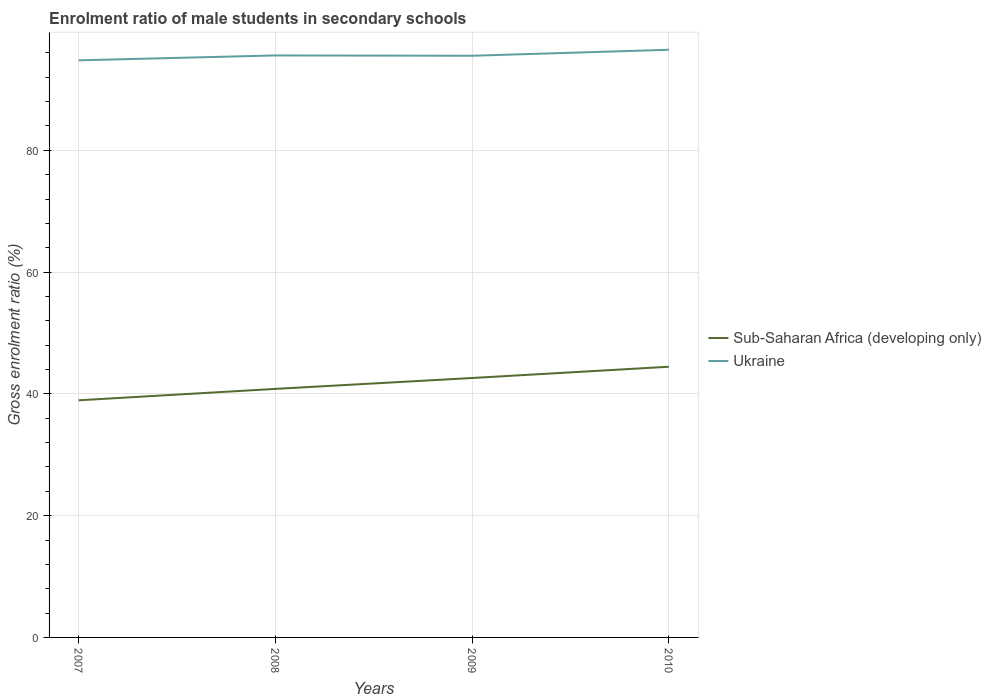Is the number of lines equal to the number of legend labels?
Make the answer very short. Yes. Across all years, what is the maximum enrolment ratio of male students in secondary schools in Sub-Saharan Africa (developing only)?
Your response must be concise. 38.94. In which year was the enrolment ratio of male students in secondary schools in Sub-Saharan Africa (developing only) maximum?
Ensure brevity in your answer.  2007. What is the total enrolment ratio of male students in secondary schools in Sub-Saharan Africa (developing only) in the graph?
Provide a short and direct response. -5.51. What is the difference between the highest and the second highest enrolment ratio of male students in secondary schools in Ukraine?
Offer a terse response. 1.73. What is the difference between the highest and the lowest enrolment ratio of male students in secondary schools in Ukraine?
Provide a short and direct response. 1. How many lines are there?
Provide a short and direct response. 2. What is the difference between two consecutive major ticks on the Y-axis?
Offer a very short reply. 20. Does the graph contain any zero values?
Offer a very short reply. No. Does the graph contain grids?
Keep it short and to the point. Yes. Where does the legend appear in the graph?
Your answer should be very brief. Center right. How many legend labels are there?
Your response must be concise. 2. How are the legend labels stacked?
Offer a terse response. Vertical. What is the title of the graph?
Give a very brief answer. Enrolment ratio of male students in secondary schools. What is the label or title of the X-axis?
Ensure brevity in your answer.  Years. What is the label or title of the Y-axis?
Provide a short and direct response. Gross enrolment ratio (%). What is the Gross enrolment ratio (%) of Sub-Saharan Africa (developing only) in 2007?
Offer a terse response. 38.94. What is the Gross enrolment ratio (%) of Ukraine in 2007?
Your answer should be compact. 94.78. What is the Gross enrolment ratio (%) in Sub-Saharan Africa (developing only) in 2008?
Your answer should be compact. 40.82. What is the Gross enrolment ratio (%) in Ukraine in 2008?
Your answer should be very brief. 95.58. What is the Gross enrolment ratio (%) of Sub-Saharan Africa (developing only) in 2009?
Keep it short and to the point. 42.61. What is the Gross enrolment ratio (%) in Ukraine in 2009?
Provide a short and direct response. 95.53. What is the Gross enrolment ratio (%) in Sub-Saharan Africa (developing only) in 2010?
Offer a terse response. 44.46. What is the Gross enrolment ratio (%) in Ukraine in 2010?
Make the answer very short. 96.51. Across all years, what is the maximum Gross enrolment ratio (%) in Sub-Saharan Africa (developing only)?
Provide a short and direct response. 44.46. Across all years, what is the maximum Gross enrolment ratio (%) of Ukraine?
Offer a terse response. 96.51. Across all years, what is the minimum Gross enrolment ratio (%) in Sub-Saharan Africa (developing only)?
Give a very brief answer. 38.94. Across all years, what is the minimum Gross enrolment ratio (%) of Ukraine?
Provide a short and direct response. 94.78. What is the total Gross enrolment ratio (%) of Sub-Saharan Africa (developing only) in the graph?
Offer a terse response. 166.82. What is the total Gross enrolment ratio (%) in Ukraine in the graph?
Your answer should be very brief. 382.4. What is the difference between the Gross enrolment ratio (%) in Sub-Saharan Africa (developing only) in 2007 and that in 2008?
Provide a succinct answer. -1.88. What is the difference between the Gross enrolment ratio (%) of Ukraine in 2007 and that in 2008?
Offer a very short reply. -0.8. What is the difference between the Gross enrolment ratio (%) in Sub-Saharan Africa (developing only) in 2007 and that in 2009?
Offer a terse response. -3.66. What is the difference between the Gross enrolment ratio (%) in Ukraine in 2007 and that in 2009?
Your answer should be very brief. -0.75. What is the difference between the Gross enrolment ratio (%) of Sub-Saharan Africa (developing only) in 2007 and that in 2010?
Your answer should be very brief. -5.51. What is the difference between the Gross enrolment ratio (%) of Ukraine in 2007 and that in 2010?
Ensure brevity in your answer.  -1.73. What is the difference between the Gross enrolment ratio (%) in Sub-Saharan Africa (developing only) in 2008 and that in 2009?
Offer a terse response. -1.79. What is the difference between the Gross enrolment ratio (%) of Ukraine in 2008 and that in 2009?
Ensure brevity in your answer.  0.05. What is the difference between the Gross enrolment ratio (%) of Sub-Saharan Africa (developing only) in 2008 and that in 2010?
Provide a succinct answer. -3.64. What is the difference between the Gross enrolment ratio (%) in Ukraine in 2008 and that in 2010?
Ensure brevity in your answer.  -0.93. What is the difference between the Gross enrolment ratio (%) of Sub-Saharan Africa (developing only) in 2009 and that in 2010?
Offer a very short reply. -1.85. What is the difference between the Gross enrolment ratio (%) of Ukraine in 2009 and that in 2010?
Give a very brief answer. -0.98. What is the difference between the Gross enrolment ratio (%) of Sub-Saharan Africa (developing only) in 2007 and the Gross enrolment ratio (%) of Ukraine in 2008?
Provide a short and direct response. -56.64. What is the difference between the Gross enrolment ratio (%) in Sub-Saharan Africa (developing only) in 2007 and the Gross enrolment ratio (%) in Ukraine in 2009?
Your answer should be very brief. -56.59. What is the difference between the Gross enrolment ratio (%) in Sub-Saharan Africa (developing only) in 2007 and the Gross enrolment ratio (%) in Ukraine in 2010?
Provide a succinct answer. -57.57. What is the difference between the Gross enrolment ratio (%) of Sub-Saharan Africa (developing only) in 2008 and the Gross enrolment ratio (%) of Ukraine in 2009?
Your answer should be very brief. -54.71. What is the difference between the Gross enrolment ratio (%) of Sub-Saharan Africa (developing only) in 2008 and the Gross enrolment ratio (%) of Ukraine in 2010?
Your answer should be compact. -55.69. What is the difference between the Gross enrolment ratio (%) of Sub-Saharan Africa (developing only) in 2009 and the Gross enrolment ratio (%) of Ukraine in 2010?
Your response must be concise. -53.91. What is the average Gross enrolment ratio (%) of Sub-Saharan Africa (developing only) per year?
Ensure brevity in your answer.  41.71. What is the average Gross enrolment ratio (%) of Ukraine per year?
Your answer should be compact. 95.6. In the year 2007, what is the difference between the Gross enrolment ratio (%) of Sub-Saharan Africa (developing only) and Gross enrolment ratio (%) of Ukraine?
Offer a terse response. -55.83. In the year 2008, what is the difference between the Gross enrolment ratio (%) in Sub-Saharan Africa (developing only) and Gross enrolment ratio (%) in Ukraine?
Your response must be concise. -54.76. In the year 2009, what is the difference between the Gross enrolment ratio (%) in Sub-Saharan Africa (developing only) and Gross enrolment ratio (%) in Ukraine?
Offer a very short reply. -52.92. In the year 2010, what is the difference between the Gross enrolment ratio (%) in Sub-Saharan Africa (developing only) and Gross enrolment ratio (%) in Ukraine?
Give a very brief answer. -52.05. What is the ratio of the Gross enrolment ratio (%) of Sub-Saharan Africa (developing only) in 2007 to that in 2008?
Your response must be concise. 0.95. What is the ratio of the Gross enrolment ratio (%) in Sub-Saharan Africa (developing only) in 2007 to that in 2009?
Keep it short and to the point. 0.91. What is the ratio of the Gross enrolment ratio (%) of Sub-Saharan Africa (developing only) in 2007 to that in 2010?
Your answer should be compact. 0.88. What is the ratio of the Gross enrolment ratio (%) of Ukraine in 2007 to that in 2010?
Your response must be concise. 0.98. What is the ratio of the Gross enrolment ratio (%) of Sub-Saharan Africa (developing only) in 2008 to that in 2009?
Your answer should be compact. 0.96. What is the ratio of the Gross enrolment ratio (%) of Ukraine in 2008 to that in 2009?
Provide a succinct answer. 1. What is the ratio of the Gross enrolment ratio (%) of Sub-Saharan Africa (developing only) in 2008 to that in 2010?
Your answer should be very brief. 0.92. What is the ratio of the Gross enrolment ratio (%) in Ukraine in 2008 to that in 2010?
Make the answer very short. 0.99. What is the ratio of the Gross enrolment ratio (%) in Ukraine in 2009 to that in 2010?
Offer a terse response. 0.99. What is the difference between the highest and the second highest Gross enrolment ratio (%) in Sub-Saharan Africa (developing only)?
Provide a succinct answer. 1.85. What is the difference between the highest and the second highest Gross enrolment ratio (%) of Ukraine?
Provide a succinct answer. 0.93. What is the difference between the highest and the lowest Gross enrolment ratio (%) in Sub-Saharan Africa (developing only)?
Make the answer very short. 5.51. What is the difference between the highest and the lowest Gross enrolment ratio (%) of Ukraine?
Your response must be concise. 1.73. 